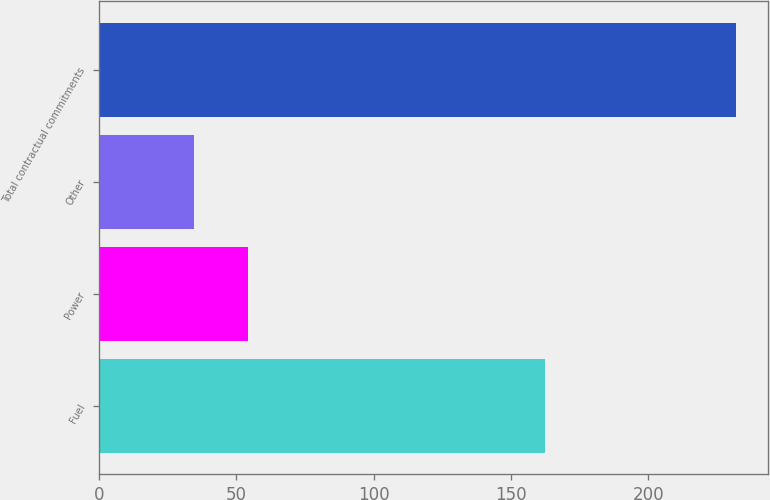Convert chart to OTSL. <chart><loc_0><loc_0><loc_500><loc_500><bar_chart><fcel>Fuel<fcel>Power<fcel>Other<fcel>Total contractual commitments<nl><fcel>162.6<fcel>54.44<fcel>34.7<fcel>232.1<nl></chart> 